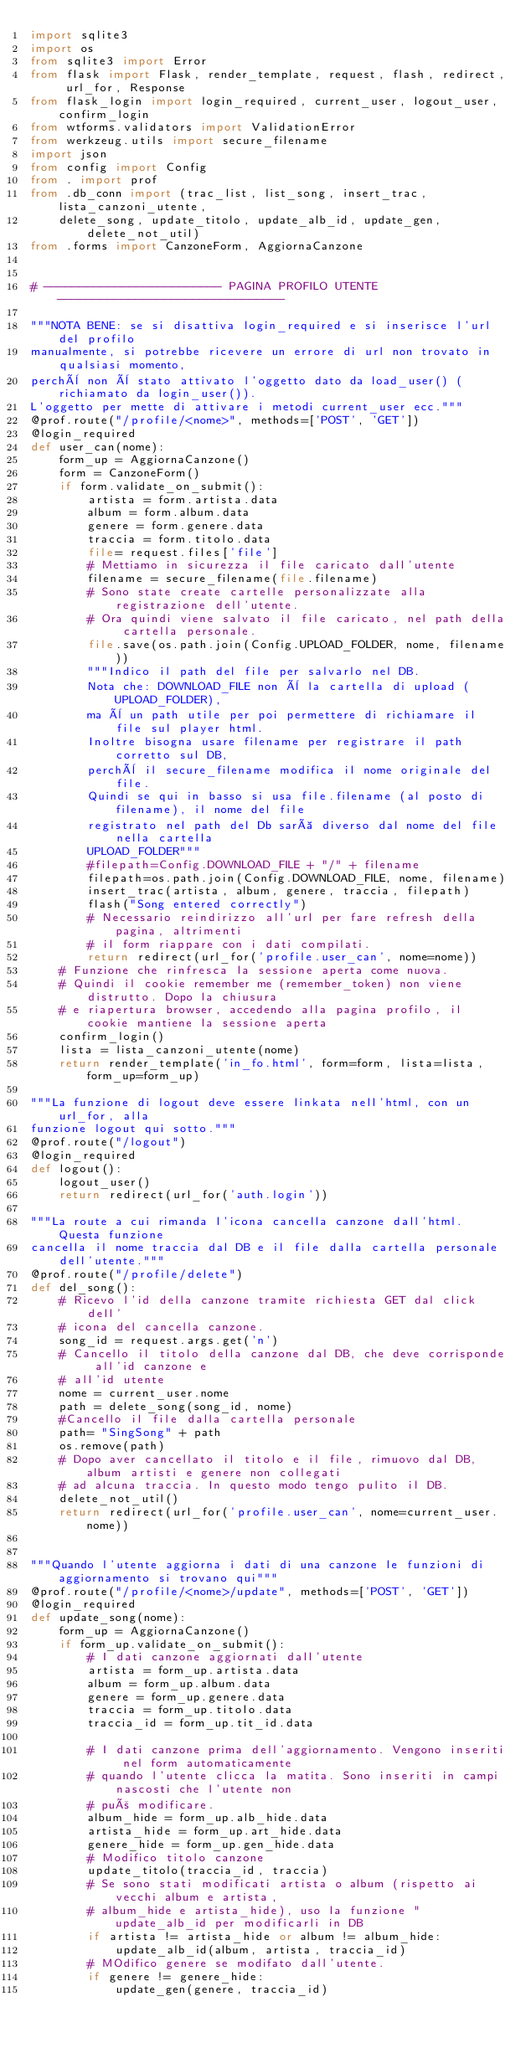Convert code to text. <code><loc_0><loc_0><loc_500><loc_500><_Python_>import sqlite3
import os
from sqlite3 import Error
from flask import Flask, render_template, request, flash, redirect, url_for, Response
from flask_login import login_required, current_user, logout_user, confirm_login
from wtforms.validators import ValidationError
from werkzeug.utils import secure_filename
import json
from config import Config
from . import prof
from .db_conn import (trac_list, list_song, insert_trac, lista_canzoni_utente,
    delete_song, update_titolo, update_alb_id, update_gen, delete_not_util)
from .forms import CanzoneForm, AggiornaCanzone


# ------------------------- PAGINA PROFILO UTENTE  --------------------------------

"""NOTA BENE: se si disattiva login_required e si inserisce l'url del profilo
manualmente, si potrebbe ricevere un errore di url non trovato in qualsiasi momento,
perchè non è stato attivato l'oggetto dato da load_user() (richiamato da login_user()).
L'oggetto per mette di attivare i metodi current_user ecc."""
@prof.route("/profile/<nome>", methods=['POST', 'GET'])
@login_required
def user_can(nome):
    form_up = AggiornaCanzone()
    form = CanzoneForm()
    if form.validate_on_submit():
        artista = form.artista.data
        album = form.album.data
        genere = form.genere.data
        traccia = form.titolo.data
        file= request.files['file']
        # Mettiamo in sicurezza il file caricato dall'utente
        filename = secure_filename(file.filename)
        # Sono state create cartelle personalizzate alla registrazione dell'utente.
        # Ora quindi viene salvato il file caricato, nel path della cartella personale.
        file.save(os.path.join(Config.UPLOAD_FOLDER, nome, filename))
        """Indico il path del file per salvarlo nel DB.
        Nota che: DOWNLOAD_FILE non è la cartella di upload (UPLOAD_FOLDER),
        ma è un path utile per poi permettere di richiamare il file sul player html.
        Inoltre bisogna usare filename per registrare il path corretto sul DB,
        perchè il secure_filename modifica il nome originale del file.
        Quindi se qui in basso si usa file.filename (al posto di filename), il nome del file
        registrato nel path del Db sarà diverso dal nome del file nella cartella
        UPLOAD_FOLDER"""
        #filepath=Config.DOWNLOAD_FILE + "/" + filename
        filepath=os.path.join(Config.DOWNLOAD_FILE, nome, filename)
        insert_trac(artista, album, genere, traccia, filepath)
        flash("Song entered correctly")
        # Necessario reindirizzo all'url per fare refresh della pagina, altrimenti
        # il form riappare con i dati compilati.
        return redirect(url_for('profile.user_can', nome=nome))
    # Funzione che rinfresca la sessione aperta come nuova.
    # Quindi il cookie remember me (remember_token) non viene distrutto. Dopo la chiusura
    # e riapertura browser, accedendo alla pagina profilo, il cookie mantiene la sessione aperta
    confirm_login()
    lista = lista_canzoni_utente(nome)
    return render_template('in_fo.html', form=form, lista=lista, form_up=form_up)

"""La funzione di logout deve essere linkata nell'html, con un url_for, alla
funzione logout qui sotto."""
@prof.route("/logout")
@login_required
def logout():
    logout_user()
    return redirect(url_for('auth.login'))

"""La route a cui rimanda l'icona cancella canzone dall'html. Questa funzione
cancella il nome traccia dal DB e il file dalla cartella personale dell'utente."""
@prof.route("/profile/delete")
def del_song():
    # Ricevo l'id della canzone tramite richiesta GET dal click dell'
    # icona del cancella canzone.
    song_id = request.args.get('n')
    # Cancello il titolo della canzone dal DB, che deve corrisponde all'id canzone e
    # all'id utente
    nome = current_user.nome
    path = delete_song(song_id, nome)
    #Cancello il file dalla cartella personale
    path= "SingSong" + path
    os.remove(path)
    # Dopo aver cancellato il titolo e il file, rimuovo dal DB, album artisti e genere non collegati
    # ad alcuna traccia. In questo modo tengo pulito il DB.
    delete_not_util()
    return redirect(url_for('profile.user_can', nome=current_user.nome))


"""Quando l'utente aggiorna i dati di una canzone le funzioni di aggiornamento si trovano qui"""
@prof.route("/profile/<nome>/update", methods=['POST', 'GET'])
@login_required
def update_song(nome):
    form_up = AggiornaCanzone()
    if form_up.validate_on_submit():
        # I dati canzone aggiornati dall'utente
        artista = form_up.artista.data
        album = form_up.album.data
        genere = form_up.genere.data
        traccia = form_up.titolo.data
        traccia_id = form_up.tit_id.data

        # I dati canzone prima dell'aggiornamento. Vengono inseriti nel form automaticamente
        # quando l'utente clicca la matita. Sono inseriti in campi nascosti che l'utente non
        # può modificare.
        album_hide = form_up.alb_hide.data
        artista_hide = form_up.art_hide.data
        genere_hide = form_up.gen_hide.data
        # Modifico titolo canzone
        update_titolo(traccia_id, traccia)
        # Se sono stati modificati artista o album (rispetto ai vecchi album e artista,
        # album_hide e artista_hide), uso la funzione "update_alb_id per modificarli in DB
        if artista != artista_hide or album != album_hide:
            update_alb_id(album, artista, traccia_id)
        # MOdifico genere se modifato dall'utente.
        if genere != genere_hide:
            update_gen(genere, traccia_id)</code> 